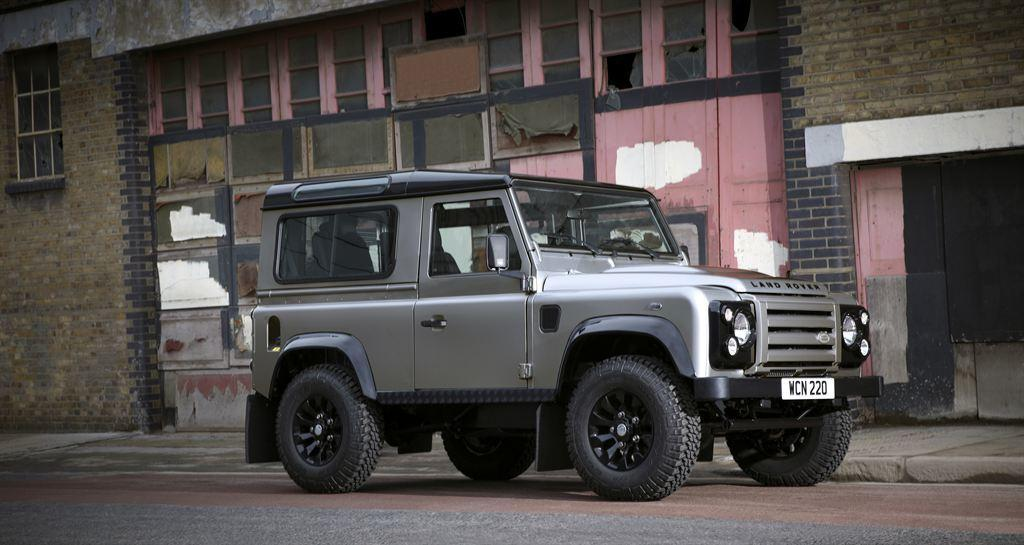Where was the image taken? The image is clicked outside. What is the main subject in the middle of the image? There is a jeep in the middle of the image. What else is present in the middle of the image? There is a building in the middle of the image. What features can be seen on the jeep? The jeep has a number plate, lights, and wheels. Can you see any beans growing near the jeep in the image? There are no beans visible in the image; it features a jeep and a building outside. Is the seashore visible in the background of the image? The seashore is not visible in the image; it is focused on a jeep, a building, and the surrounding outdoor environment. 